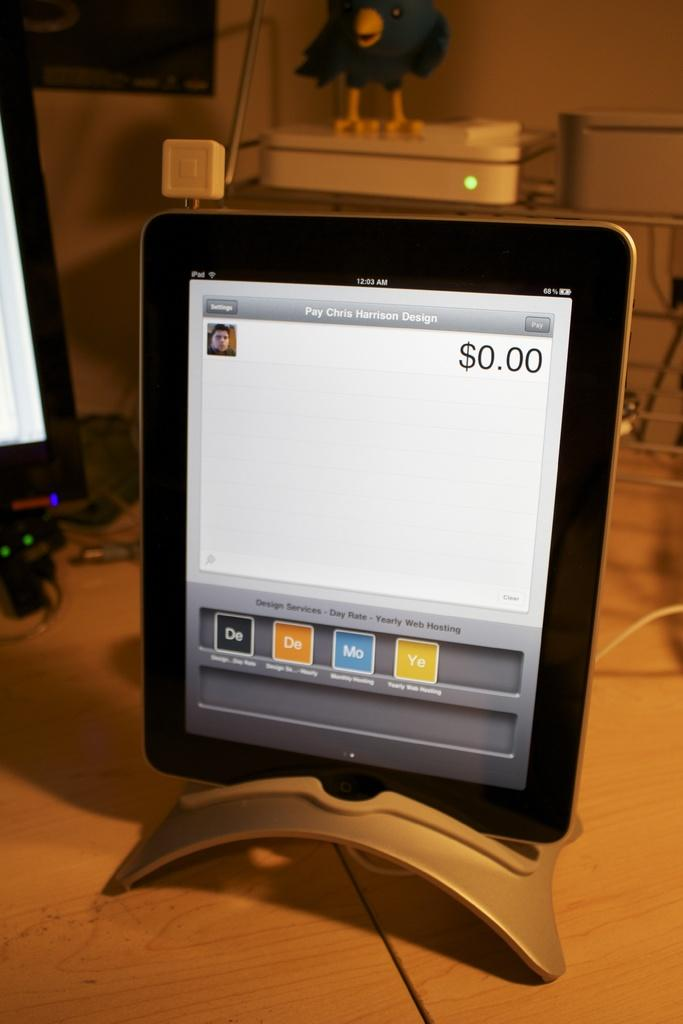Provide a one-sentence caption for the provided image. A tablet sitting on a desk that has Pay Chris Harrison Design on the screen. 